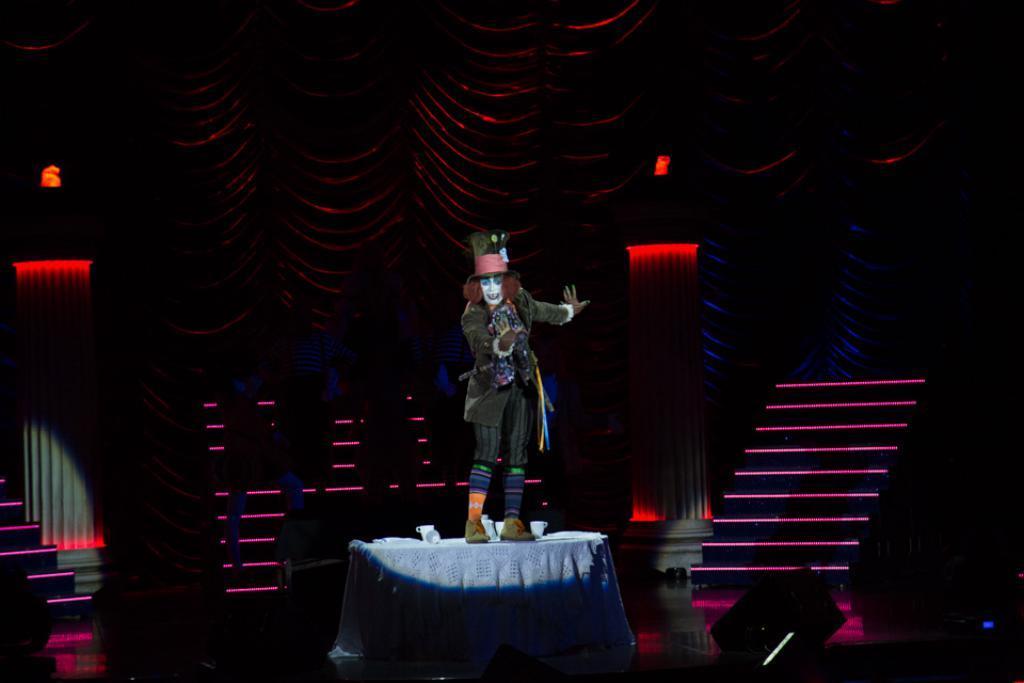Can you describe this image briefly? In the image we can see there is a person wearing jacket and hat standing on the table. There are stairs and there are lights. There are pillars and there is a curtain. Background of the image is dark. 